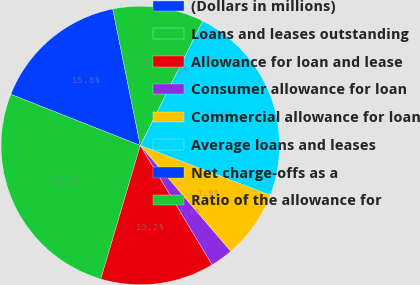Convert chart to OTSL. <chart><loc_0><loc_0><loc_500><loc_500><pie_chart><fcel>(Dollars in millions)<fcel>Loans and leases outstanding<fcel>Allowance for loan and lease<fcel>Consumer allowance for loan<fcel>Commercial allowance for loan<fcel>Average loans and leases<fcel>Net charge-offs as a<fcel>Ratio of the allowance for<nl><fcel>15.84%<fcel>26.41%<fcel>13.2%<fcel>2.64%<fcel>7.92%<fcel>23.42%<fcel>0.0%<fcel>10.56%<nl></chart> 